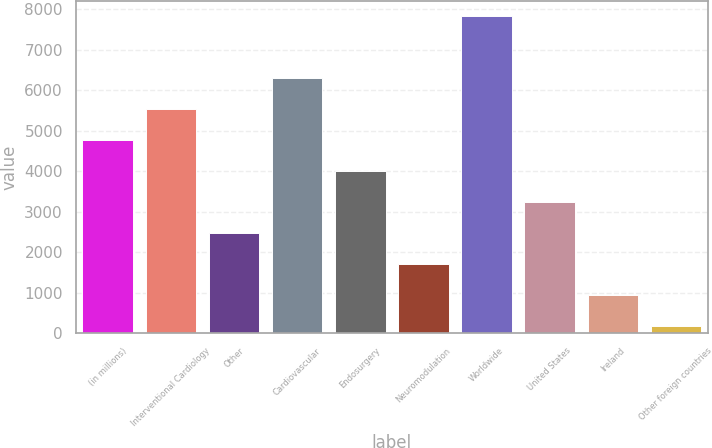Convert chart to OTSL. <chart><loc_0><loc_0><loc_500><loc_500><bar_chart><fcel>(in millions)<fcel>Interventional Cardiology<fcel>Other<fcel>Cardiovascular<fcel>Endosurgery<fcel>Neuromodulation<fcel>Worldwide<fcel>United States<fcel>Ireland<fcel>Other foreign countries<nl><fcel>4766.2<fcel>5529.9<fcel>2475.1<fcel>6293.6<fcel>4002.5<fcel>1711.4<fcel>7821<fcel>3238.8<fcel>947.7<fcel>184<nl></chart> 